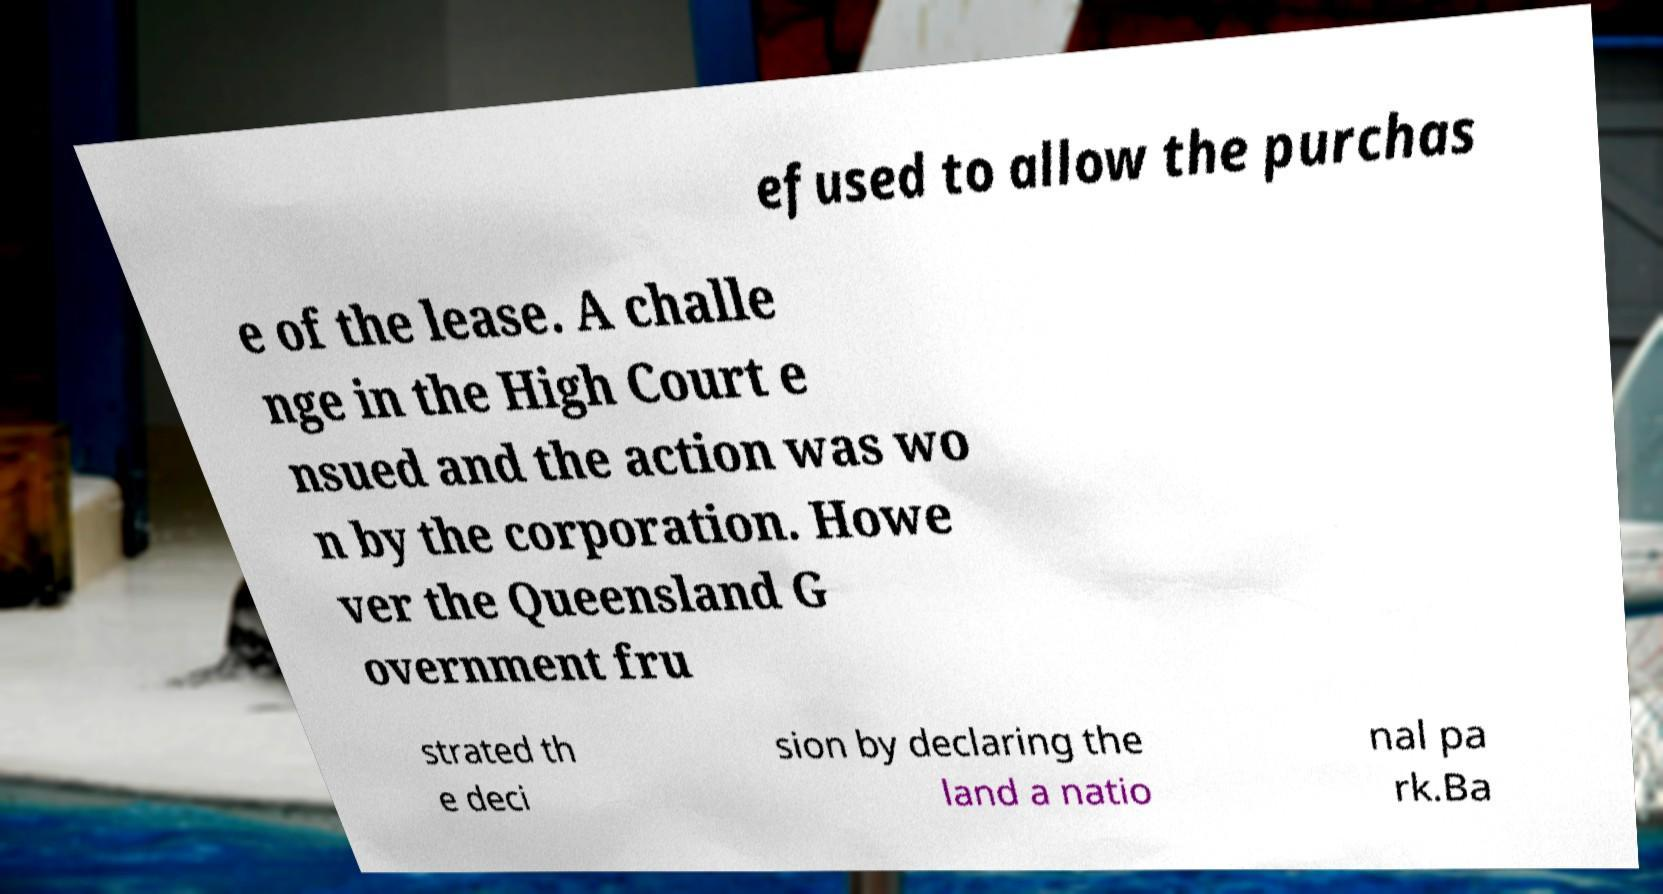Please identify and transcribe the text found in this image. efused to allow the purchas e of the lease. A challe nge in the High Court e nsued and the action was wo n by the corporation. Howe ver the Queensland G overnment fru strated th e deci sion by declaring the land a natio nal pa rk.Ba 